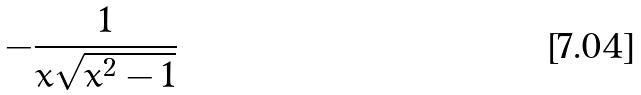Convert formula to latex. <formula><loc_0><loc_0><loc_500><loc_500>- \frac { 1 } { x \sqrt { x ^ { 2 } - 1 } }</formula> 